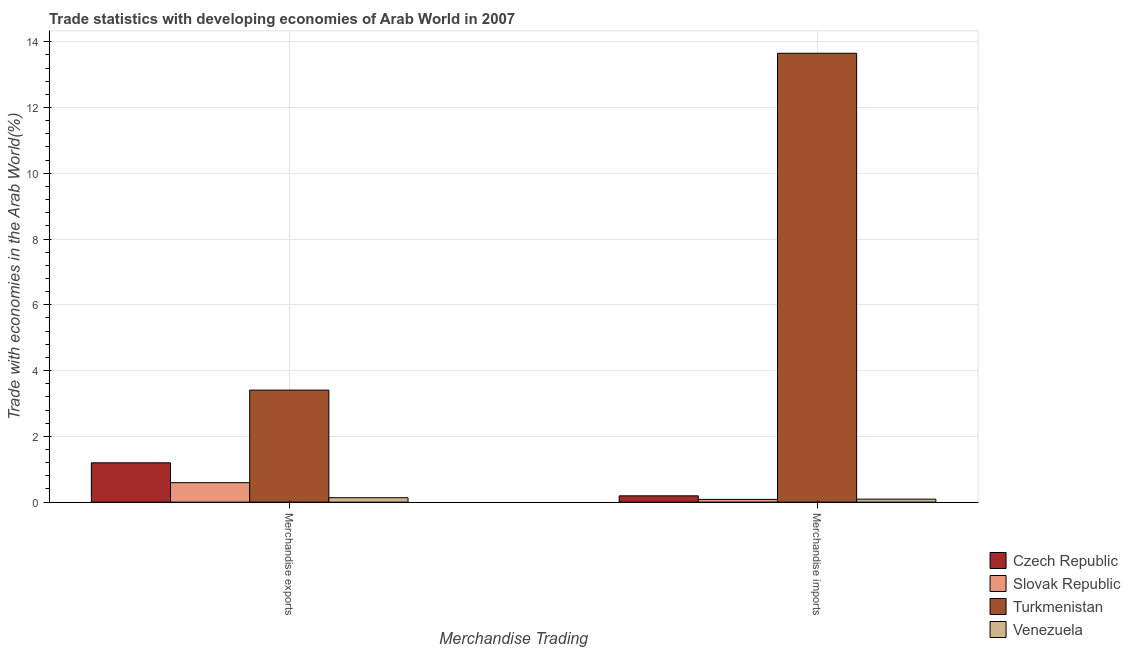Are the number of bars on each tick of the X-axis equal?
Provide a short and direct response. Yes. How many bars are there on the 1st tick from the right?
Offer a very short reply. 4. What is the label of the 2nd group of bars from the left?
Keep it short and to the point. Merchandise imports. What is the merchandise imports in Czech Republic?
Your answer should be very brief. 0.19. Across all countries, what is the maximum merchandise imports?
Offer a very short reply. 13.65. Across all countries, what is the minimum merchandise imports?
Your answer should be very brief. 0.08. In which country was the merchandise exports maximum?
Offer a very short reply. Turkmenistan. In which country was the merchandise imports minimum?
Offer a very short reply. Slovak Republic. What is the total merchandise imports in the graph?
Ensure brevity in your answer.  14.02. What is the difference between the merchandise exports in Czech Republic and that in Venezuela?
Ensure brevity in your answer.  1.06. What is the difference between the merchandise exports in Czech Republic and the merchandise imports in Venezuela?
Keep it short and to the point. 1.11. What is the average merchandise exports per country?
Your answer should be very brief. 1.33. What is the difference between the merchandise exports and merchandise imports in Turkmenistan?
Give a very brief answer. -10.24. In how many countries, is the merchandise exports greater than 12 %?
Your answer should be very brief. 0. What is the ratio of the merchandise imports in Venezuela to that in Czech Republic?
Your answer should be compact. 0.47. What does the 3rd bar from the left in Merchandise exports represents?
Make the answer very short. Turkmenistan. What does the 4th bar from the right in Merchandise imports represents?
Provide a succinct answer. Czech Republic. Does the graph contain grids?
Offer a very short reply. Yes. Where does the legend appear in the graph?
Ensure brevity in your answer.  Bottom right. How many legend labels are there?
Keep it short and to the point. 4. How are the legend labels stacked?
Provide a short and direct response. Vertical. What is the title of the graph?
Give a very brief answer. Trade statistics with developing economies of Arab World in 2007. Does "Guyana" appear as one of the legend labels in the graph?
Make the answer very short. No. What is the label or title of the X-axis?
Offer a terse response. Merchandise Trading. What is the label or title of the Y-axis?
Provide a succinct answer. Trade with economies in the Arab World(%). What is the Trade with economies in the Arab World(%) of Czech Republic in Merchandise exports?
Your answer should be compact. 1.2. What is the Trade with economies in the Arab World(%) in Slovak Republic in Merchandise exports?
Your answer should be very brief. 0.59. What is the Trade with economies in the Arab World(%) of Turkmenistan in Merchandise exports?
Offer a very short reply. 3.41. What is the Trade with economies in the Arab World(%) in Venezuela in Merchandise exports?
Ensure brevity in your answer.  0.13. What is the Trade with economies in the Arab World(%) in Czech Republic in Merchandise imports?
Your answer should be compact. 0.19. What is the Trade with economies in the Arab World(%) of Slovak Republic in Merchandise imports?
Provide a succinct answer. 0.08. What is the Trade with economies in the Arab World(%) in Turkmenistan in Merchandise imports?
Provide a short and direct response. 13.65. What is the Trade with economies in the Arab World(%) in Venezuela in Merchandise imports?
Ensure brevity in your answer.  0.09. Across all Merchandise Trading, what is the maximum Trade with economies in the Arab World(%) in Czech Republic?
Provide a succinct answer. 1.2. Across all Merchandise Trading, what is the maximum Trade with economies in the Arab World(%) of Slovak Republic?
Provide a short and direct response. 0.59. Across all Merchandise Trading, what is the maximum Trade with economies in the Arab World(%) in Turkmenistan?
Offer a terse response. 13.65. Across all Merchandise Trading, what is the maximum Trade with economies in the Arab World(%) in Venezuela?
Your response must be concise. 0.13. Across all Merchandise Trading, what is the minimum Trade with economies in the Arab World(%) in Czech Republic?
Your answer should be very brief. 0.19. Across all Merchandise Trading, what is the minimum Trade with economies in the Arab World(%) of Slovak Republic?
Make the answer very short. 0.08. Across all Merchandise Trading, what is the minimum Trade with economies in the Arab World(%) of Turkmenistan?
Your answer should be very brief. 3.41. Across all Merchandise Trading, what is the minimum Trade with economies in the Arab World(%) in Venezuela?
Offer a terse response. 0.09. What is the total Trade with economies in the Arab World(%) in Czech Republic in the graph?
Offer a very short reply. 1.39. What is the total Trade with economies in the Arab World(%) of Slovak Republic in the graph?
Your answer should be very brief. 0.68. What is the total Trade with economies in the Arab World(%) of Turkmenistan in the graph?
Offer a terse response. 17.06. What is the total Trade with economies in the Arab World(%) in Venezuela in the graph?
Ensure brevity in your answer.  0.22. What is the difference between the Trade with economies in the Arab World(%) in Slovak Republic in Merchandise exports and that in Merchandise imports?
Provide a succinct answer. 0.51. What is the difference between the Trade with economies in the Arab World(%) of Turkmenistan in Merchandise exports and that in Merchandise imports?
Offer a very short reply. -10.24. What is the difference between the Trade with economies in the Arab World(%) of Venezuela in Merchandise exports and that in Merchandise imports?
Give a very brief answer. 0.04. What is the difference between the Trade with economies in the Arab World(%) in Czech Republic in Merchandise exports and the Trade with economies in the Arab World(%) in Slovak Republic in Merchandise imports?
Make the answer very short. 1.11. What is the difference between the Trade with economies in the Arab World(%) in Czech Republic in Merchandise exports and the Trade with economies in the Arab World(%) in Turkmenistan in Merchandise imports?
Your answer should be compact. -12.45. What is the difference between the Trade with economies in the Arab World(%) of Czech Republic in Merchandise exports and the Trade with economies in the Arab World(%) of Venezuela in Merchandise imports?
Offer a terse response. 1.11. What is the difference between the Trade with economies in the Arab World(%) of Slovak Republic in Merchandise exports and the Trade with economies in the Arab World(%) of Turkmenistan in Merchandise imports?
Give a very brief answer. -13.06. What is the difference between the Trade with economies in the Arab World(%) of Slovak Republic in Merchandise exports and the Trade with economies in the Arab World(%) of Venezuela in Merchandise imports?
Offer a very short reply. 0.5. What is the difference between the Trade with economies in the Arab World(%) in Turkmenistan in Merchandise exports and the Trade with economies in the Arab World(%) in Venezuela in Merchandise imports?
Offer a terse response. 3.32. What is the average Trade with economies in the Arab World(%) in Czech Republic per Merchandise Trading?
Your answer should be very brief. 0.69. What is the average Trade with economies in the Arab World(%) in Slovak Republic per Merchandise Trading?
Offer a terse response. 0.34. What is the average Trade with economies in the Arab World(%) of Turkmenistan per Merchandise Trading?
Make the answer very short. 8.53. What is the average Trade with economies in the Arab World(%) in Venezuela per Merchandise Trading?
Provide a short and direct response. 0.11. What is the difference between the Trade with economies in the Arab World(%) of Czech Republic and Trade with economies in the Arab World(%) of Slovak Republic in Merchandise exports?
Your answer should be compact. 0.6. What is the difference between the Trade with economies in the Arab World(%) of Czech Republic and Trade with economies in the Arab World(%) of Turkmenistan in Merchandise exports?
Your response must be concise. -2.21. What is the difference between the Trade with economies in the Arab World(%) of Czech Republic and Trade with economies in the Arab World(%) of Venezuela in Merchandise exports?
Offer a terse response. 1.06. What is the difference between the Trade with economies in the Arab World(%) in Slovak Republic and Trade with economies in the Arab World(%) in Turkmenistan in Merchandise exports?
Give a very brief answer. -2.81. What is the difference between the Trade with economies in the Arab World(%) of Slovak Republic and Trade with economies in the Arab World(%) of Venezuela in Merchandise exports?
Provide a succinct answer. 0.46. What is the difference between the Trade with economies in the Arab World(%) in Turkmenistan and Trade with economies in the Arab World(%) in Venezuela in Merchandise exports?
Provide a short and direct response. 3.27. What is the difference between the Trade with economies in the Arab World(%) of Czech Republic and Trade with economies in the Arab World(%) of Slovak Republic in Merchandise imports?
Ensure brevity in your answer.  0.11. What is the difference between the Trade with economies in the Arab World(%) in Czech Republic and Trade with economies in the Arab World(%) in Turkmenistan in Merchandise imports?
Provide a short and direct response. -13.46. What is the difference between the Trade with economies in the Arab World(%) of Czech Republic and Trade with economies in the Arab World(%) of Venezuela in Merchandise imports?
Your answer should be compact. 0.1. What is the difference between the Trade with economies in the Arab World(%) in Slovak Republic and Trade with economies in the Arab World(%) in Turkmenistan in Merchandise imports?
Your response must be concise. -13.57. What is the difference between the Trade with economies in the Arab World(%) in Slovak Republic and Trade with economies in the Arab World(%) in Venezuela in Merchandise imports?
Keep it short and to the point. -0.01. What is the difference between the Trade with economies in the Arab World(%) in Turkmenistan and Trade with economies in the Arab World(%) in Venezuela in Merchandise imports?
Provide a short and direct response. 13.56. What is the ratio of the Trade with economies in the Arab World(%) of Czech Republic in Merchandise exports to that in Merchandise imports?
Offer a very short reply. 6.25. What is the ratio of the Trade with economies in the Arab World(%) of Slovak Republic in Merchandise exports to that in Merchandise imports?
Provide a short and direct response. 7.08. What is the ratio of the Trade with economies in the Arab World(%) of Turkmenistan in Merchandise exports to that in Merchandise imports?
Provide a succinct answer. 0.25. What is the ratio of the Trade with economies in the Arab World(%) in Venezuela in Merchandise exports to that in Merchandise imports?
Your answer should be very brief. 1.48. What is the difference between the highest and the second highest Trade with economies in the Arab World(%) in Slovak Republic?
Offer a very short reply. 0.51. What is the difference between the highest and the second highest Trade with economies in the Arab World(%) of Turkmenistan?
Provide a succinct answer. 10.24. What is the difference between the highest and the second highest Trade with economies in the Arab World(%) in Venezuela?
Give a very brief answer. 0.04. What is the difference between the highest and the lowest Trade with economies in the Arab World(%) of Czech Republic?
Your response must be concise. 1. What is the difference between the highest and the lowest Trade with economies in the Arab World(%) of Slovak Republic?
Provide a succinct answer. 0.51. What is the difference between the highest and the lowest Trade with economies in the Arab World(%) of Turkmenistan?
Ensure brevity in your answer.  10.24. What is the difference between the highest and the lowest Trade with economies in the Arab World(%) of Venezuela?
Your answer should be very brief. 0.04. 